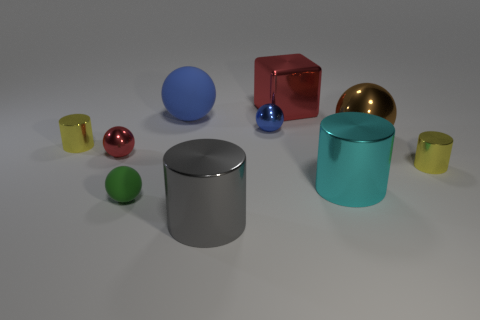Subtract all big brown balls. How many balls are left? 4 Subtract all yellow spheres. Subtract all brown cylinders. How many spheres are left? 5 Subtract all cylinders. How many objects are left? 6 Subtract all gray shiny cylinders. Subtract all blue matte things. How many objects are left? 8 Add 2 big cyan metallic cylinders. How many big cyan metallic cylinders are left? 3 Add 3 metallic blocks. How many metallic blocks exist? 4 Subtract 0 red cylinders. How many objects are left? 10 